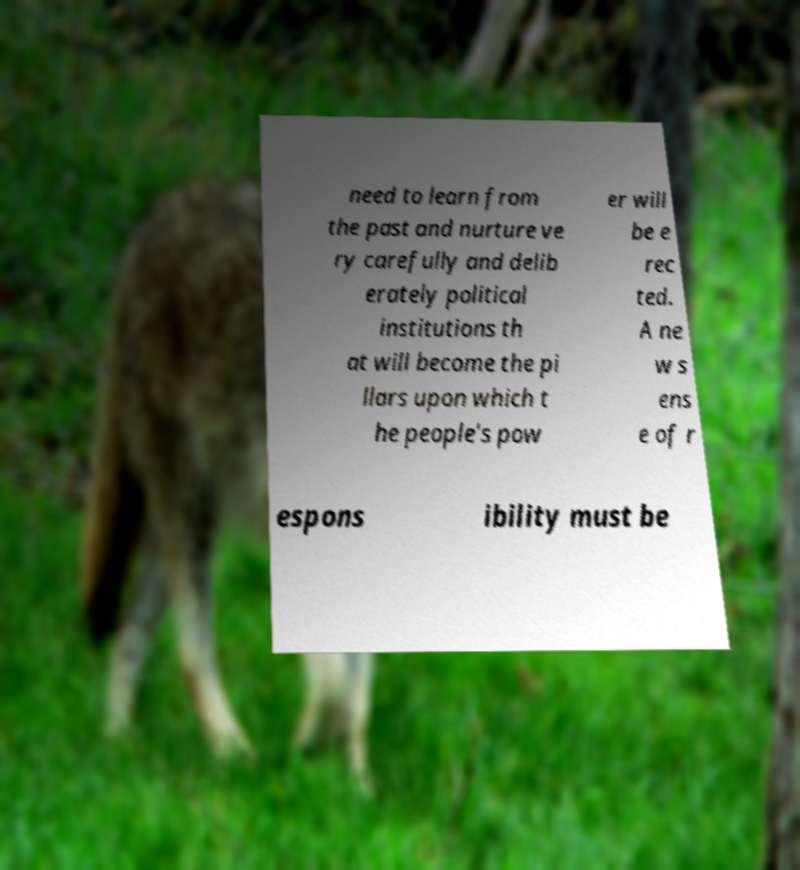There's text embedded in this image that I need extracted. Can you transcribe it verbatim? need to learn from the past and nurture ve ry carefully and delib erately political institutions th at will become the pi llars upon which t he people's pow er will be e rec ted. A ne w s ens e of r espons ibility must be 